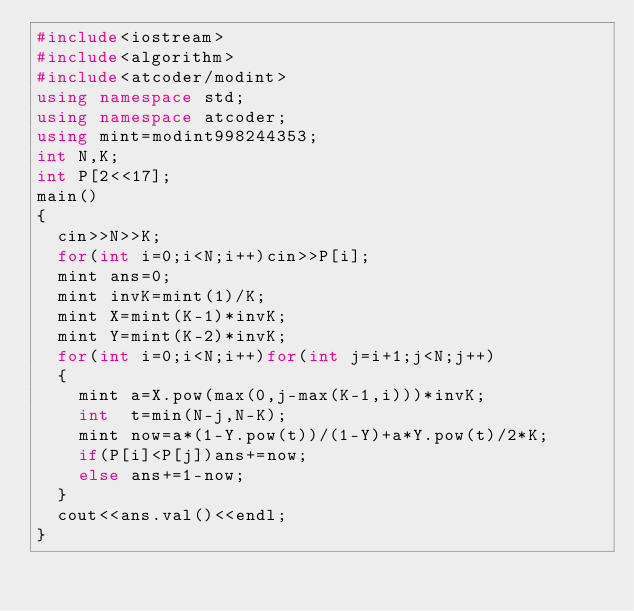<code> <loc_0><loc_0><loc_500><loc_500><_C++_>#include<iostream>
#include<algorithm>
#include<atcoder/modint>
using namespace std;
using namespace atcoder;
using mint=modint998244353;
int N,K;
int P[2<<17];
main()
{
	cin>>N>>K;
	for(int i=0;i<N;i++)cin>>P[i];
	mint ans=0;
	mint invK=mint(1)/K;
	mint X=mint(K-1)*invK;
	mint Y=mint(K-2)*invK;
	for(int i=0;i<N;i++)for(int j=i+1;j<N;j++)
	{
		mint a=X.pow(max(0,j-max(K-1,i)))*invK;
		int  t=min(N-j,N-K);
		mint now=a*(1-Y.pow(t))/(1-Y)+a*Y.pow(t)/2*K;
		if(P[i]<P[j])ans+=now;
		else ans+=1-now;
	}
	cout<<ans.val()<<endl;
}
</code> 